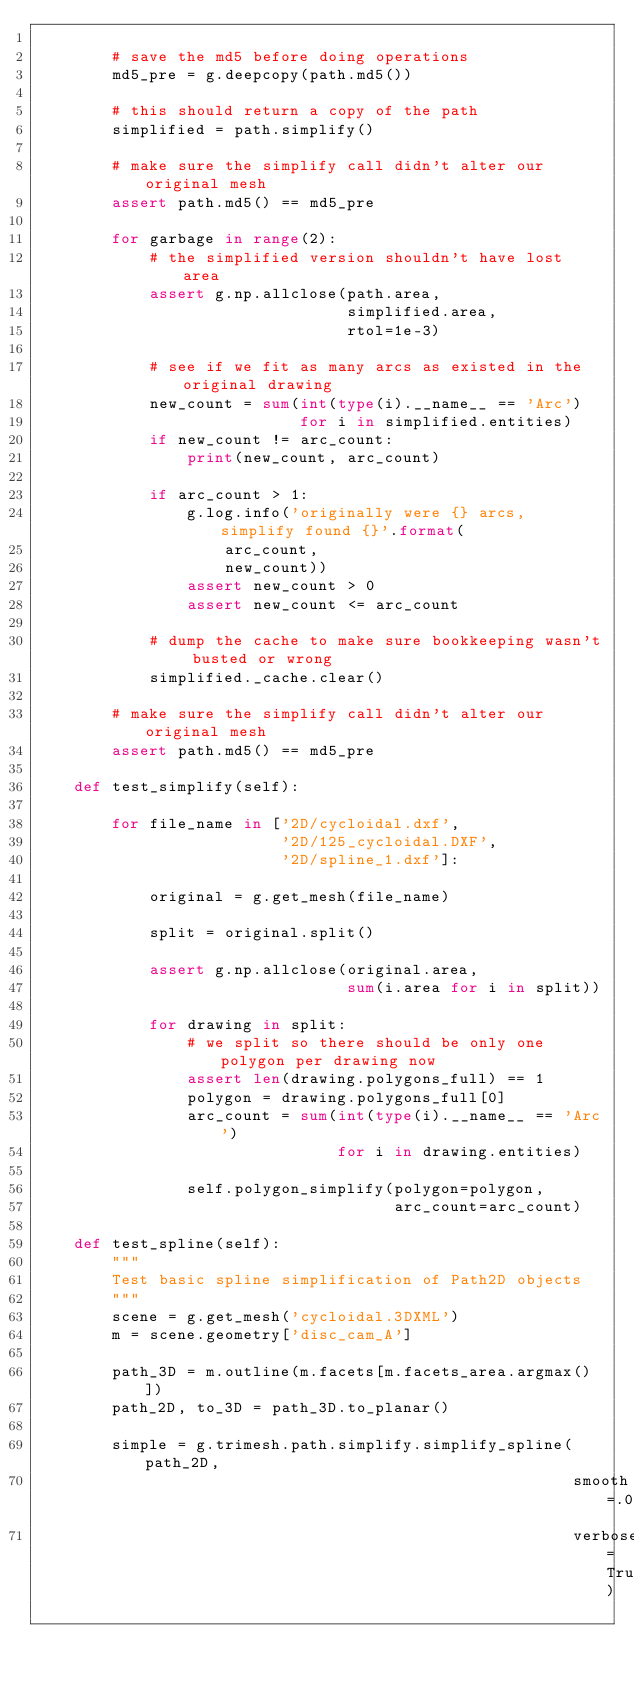<code> <loc_0><loc_0><loc_500><loc_500><_Python_>
        # save the md5 before doing operations
        md5_pre = g.deepcopy(path.md5())

        # this should return a copy of the path
        simplified = path.simplify()

        # make sure the simplify call didn't alter our original mesh
        assert path.md5() == md5_pre

        for garbage in range(2):
            # the simplified version shouldn't have lost area
            assert g.np.allclose(path.area,
                                 simplified.area,
                                 rtol=1e-3)

            # see if we fit as many arcs as existed in the original drawing
            new_count = sum(int(type(i).__name__ == 'Arc')
                            for i in simplified.entities)
            if new_count != arc_count:
                print(new_count, arc_count)

            if arc_count > 1:
                g.log.info('originally were {} arcs, simplify found {}'.format(
                    arc_count,
                    new_count))
                assert new_count > 0
                assert new_count <= arc_count

            # dump the cache to make sure bookkeeping wasn't busted or wrong
            simplified._cache.clear()

        # make sure the simplify call didn't alter our original mesh
        assert path.md5() == md5_pre

    def test_simplify(self):

        for file_name in ['2D/cycloidal.dxf',
                          '2D/125_cycloidal.DXF',
                          '2D/spline_1.dxf']:

            original = g.get_mesh(file_name)

            split = original.split()

            assert g.np.allclose(original.area,
                                 sum(i.area for i in split))

            for drawing in split:
                # we split so there should be only one polygon per drawing now
                assert len(drawing.polygons_full) == 1
                polygon = drawing.polygons_full[0]
                arc_count = sum(int(type(i).__name__ == 'Arc')
                                for i in drawing.entities)

                self.polygon_simplify(polygon=polygon,
                                      arc_count=arc_count)

    def test_spline(self):
        """
        Test basic spline simplification of Path2D objects
        """
        scene = g.get_mesh('cycloidal.3DXML')
        m = scene.geometry['disc_cam_A']

        path_3D = m.outline(m.facets[m.facets_area.argmax()])
        path_2D, to_3D = path_3D.to_planar()

        simple = g.trimesh.path.simplify.simplify_spline(path_2D,
                                                         smooth=.01,
                                                         verbose=True)</code> 